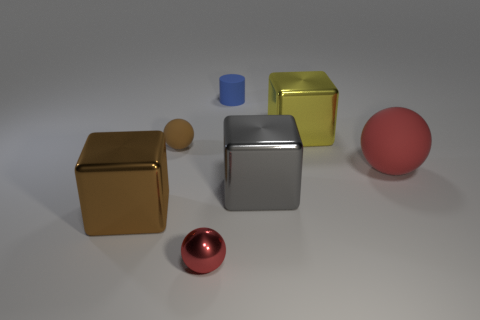Is the tiny metal object the same color as the large matte sphere?
Ensure brevity in your answer.  Yes. Is there any other thing that is the same color as the small shiny object?
Offer a very short reply. Yes. What is the shape of the large thing that is the same color as the metal sphere?
Make the answer very short. Sphere. Does the tiny matte thing that is left of the small red shiny sphere have the same shape as the small object in front of the tiny rubber sphere?
Provide a succinct answer. Yes. There is a matte thing on the left side of the small blue rubber cylinder; what color is it?
Ensure brevity in your answer.  Brown. Are there fewer red matte things that are to the left of the big rubber thing than shiny objects that are behind the large brown cube?
Ensure brevity in your answer.  Yes. What number of other objects are there of the same material as the tiny red sphere?
Your response must be concise. 3. Are the large yellow cube and the brown block made of the same material?
Offer a terse response. Yes. What number of other objects are there of the same size as the blue rubber cylinder?
Offer a terse response. 2. There is a metallic object that is behind the red sphere right of the gray object; what size is it?
Your answer should be very brief. Large. 